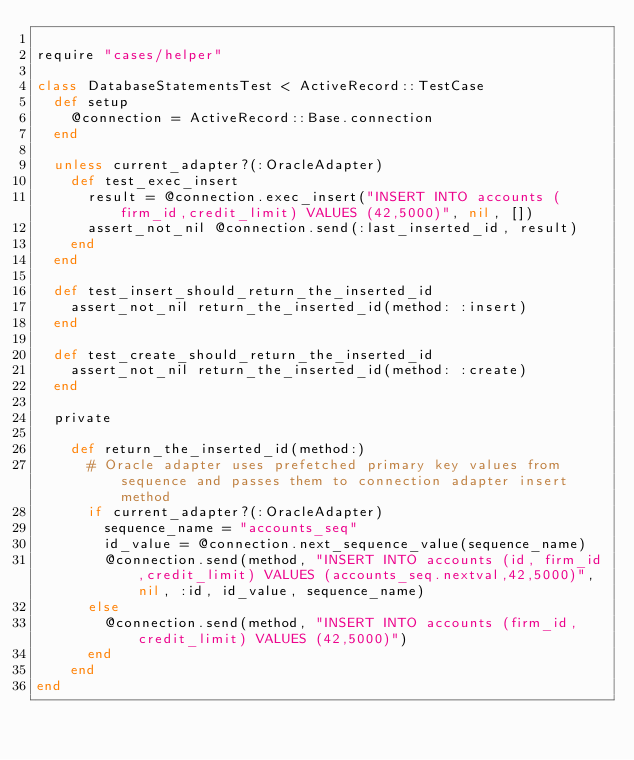Convert code to text. <code><loc_0><loc_0><loc_500><loc_500><_Ruby_>
require "cases/helper"

class DatabaseStatementsTest < ActiveRecord::TestCase
  def setup
    @connection = ActiveRecord::Base.connection
  end

  unless current_adapter?(:OracleAdapter)
    def test_exec_insert
      result = @connection.exec_insert("INSERT INTO accounts (firm_id,credit_limit) VALUES (42,5000)", nil, [])
      assert_not_nil @connection.send(:last_inserted_id, result)
    end
  end

  def test_insert_should_return_the_inserted_id
    assert_not_nil return_the_inserted_id(method: :insert)
  end

  def test_create_should_return_the_inserted_id
    assert_not_nil return_the_inserted_id(method: :create)
  end

  private

    def return_the_inserted_id(method:)
      # Oracle adapter uses prefetched primary key values from sequence and passes them to connection adapter insert method
      if current_adapter?(:OracleAdapter)
        sequence_name = "accounts_seq"
        id_value = @connection.next_sequence_value(sequence_name)
        @connection.send(method, "INSERT INTO accounts (id, firm_id,credit_limit) VALUES (accounts_seq.nextval,42,5000)", nil, :id, id_value, sequence_name)
      else
        @connection.send(method, "INSERT INTO accounts (firm_id,credit_limit) VALUES (42,5000)")
      end
    end
end
</code> 